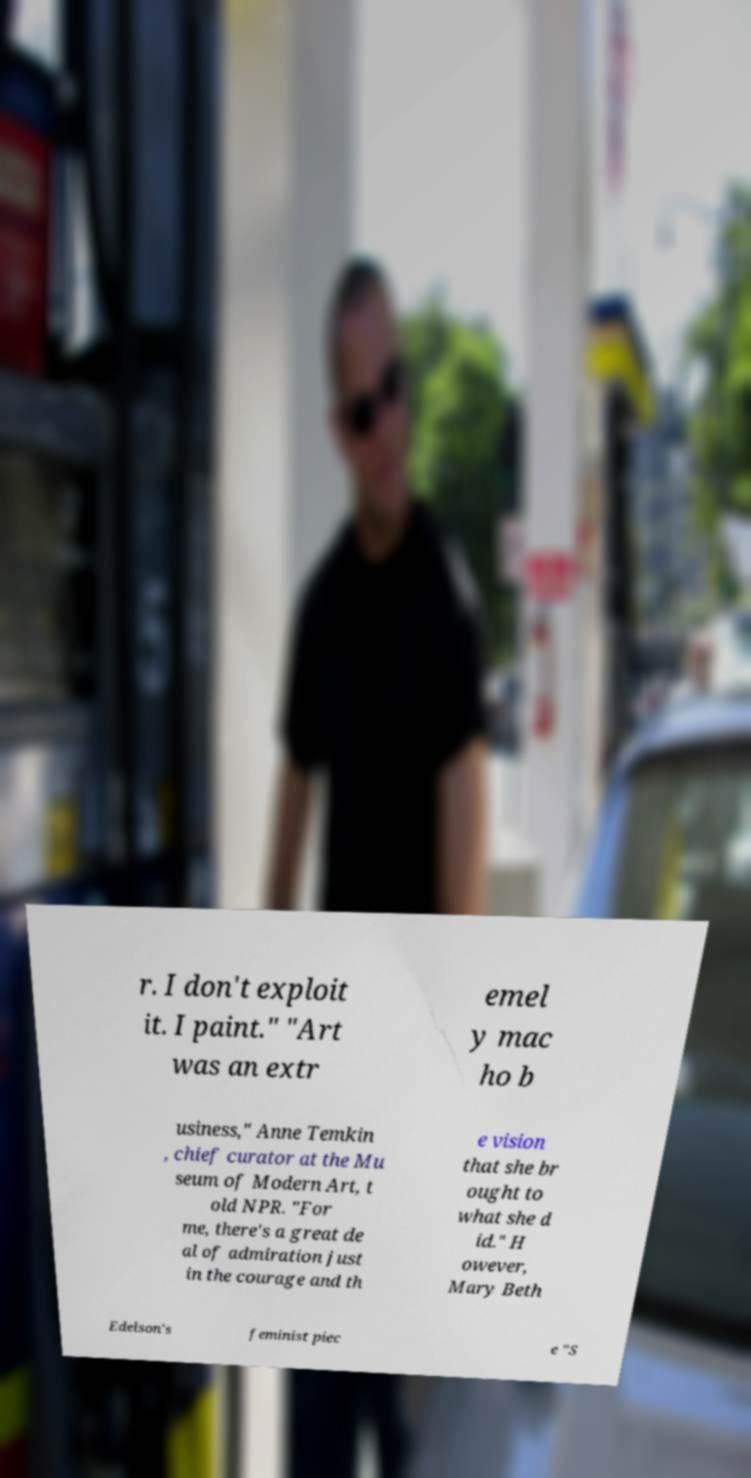Could you assist in decoding the text presented in this image and type it out clearly? r. I don't exploit it. I paint." "Art was an extr emel y mac ho b usiness," Anne Temkin , chief curator at the Mu seum of Modern Art, t old NPR. "For me, there's a great de al of admiration just in the courage and th e vision that she br ought to what she d id." H owever, Mary Beth Edelson's feminist piec e "S 